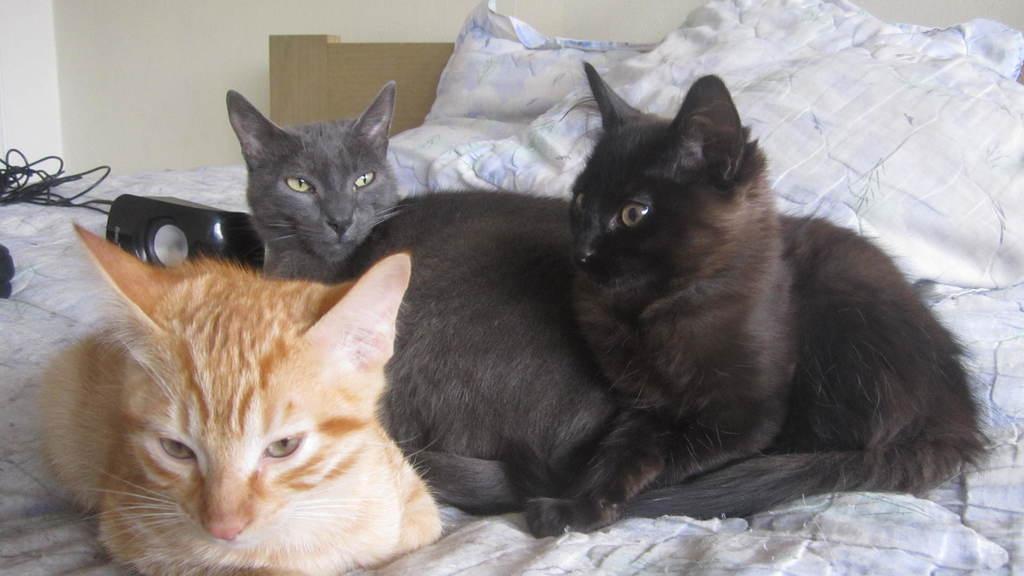Please provide a concise description of this image. In this image I can see three cats sitting on the bed. They are in black,grey and brown color. I can see white color bed-sheet. The wall is in white color wall. 